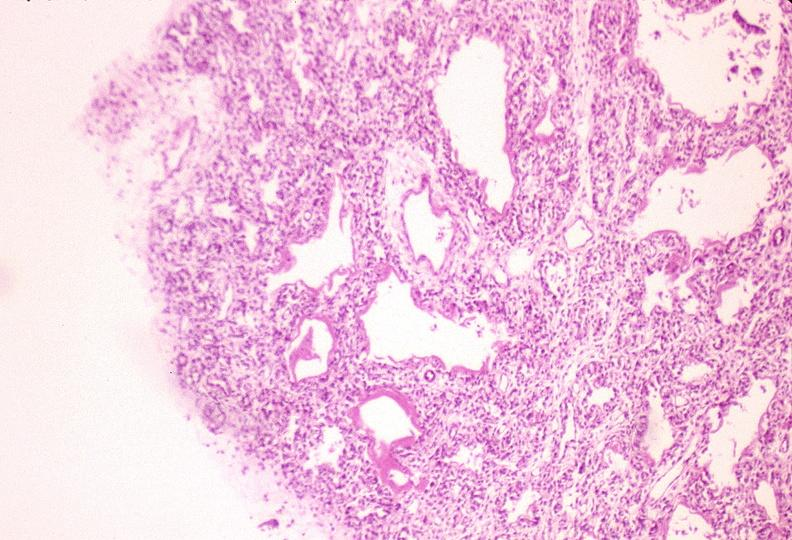where is this?
Answer the question using a single word or phrase. Lung 